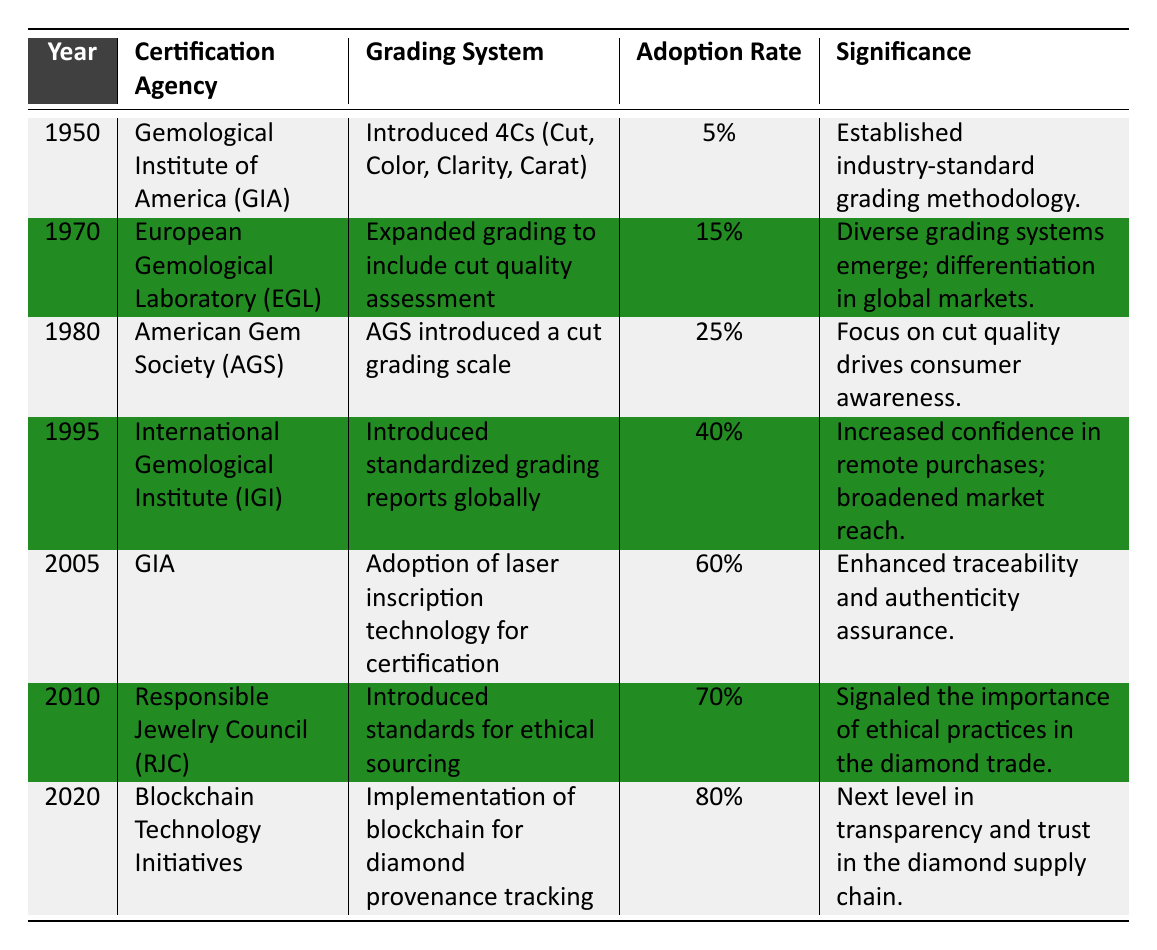What was the grading system introduced by the GIA in 1950? According to the table, the grading system introduced by the GIA in 1950 was the 4Cs, which stands for Cut, Color, Clarity, and Carat.
Answer: 4Cs (Cut, Color, Clarity, Carat) Which certification agency had an adoption rate of 15%? The table indicates that the European Gemological Laboratory (EGL) had an adoption rate of 15%.
Answer: European Gemological Laboratory (EGL) What is the average adoption rate of certification from 1950 to 2020? To find the average adoption rate, we sum the rates: 5 + 15 + 25 + 40 + 60 + 70 + 80 = 305. There are 7 values, so the average is 305/7 ≈ 43.57.
Answer: 43.57% Was the AGS the first agency to introduce a grading scale for diamonds? No, the AGS introduced a cut grading scale in 1980, while the GIA established the 4Cs grading methodology in 1950, making GIA the first.
Answer: No Which agency introduced standards for ethical sourcing and in what year? The Responsible Jewelry Council (RJC) introduced standards for ethical sourcing in the year 2010, as stated in the table.
Answer: Responsible Jewelry Council (RJC), 2010 From which year did the adoption rate increase to over 60%, and which agency was responsible? The adoption rate increased to over 60% in 2005, with the GIA being the agency responsible, as seen in the table.
Answer: 2005, GIA Identify the three certification agencies that contributed to the highest adoption rates leading up to 2020. The top three agencies based on the highest adoption rates in the table are: GIA (60%), RJC (70%), and blockchain initiatives (80%).
Answer: GIA, RJC, Blockchain Technology Initiatives How did the introduction of blockchain technology in 2020 impact the perceived significance of diamond procurement? The table indicates that blockchain technology in 2020 enhanced transparency and trust in the diamond supply chain, thus improving consumer confidence and procurement methods.
Answer: Enhanced transparency and trust What was the significance of standardized grading reports introduced by IGI in 1995? The significance of the standardized grading reports by IGI was that it increased confidence in remote purchases and broadened market reach, as highlighted in the table.
Answer: Increased confidence in remote purchases 